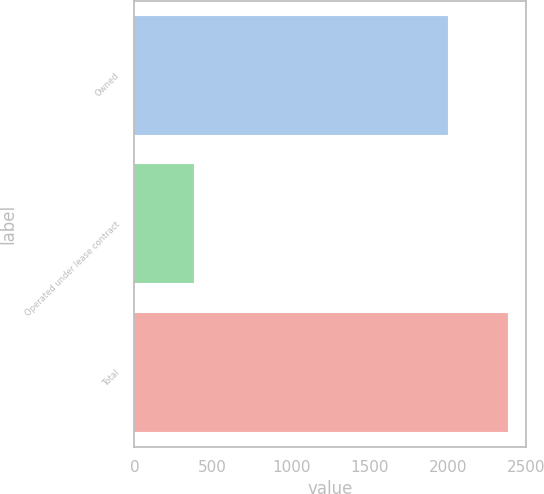Convert chart to OTSL. <chart><loc_0><loc_0><loc_500><loc_500><bar_chart><fcel>Owned<fcel>Operated under lease contract<fcel>Total<nl><fcel>2001<fcel>381<fcel>2382<nl></chart> 